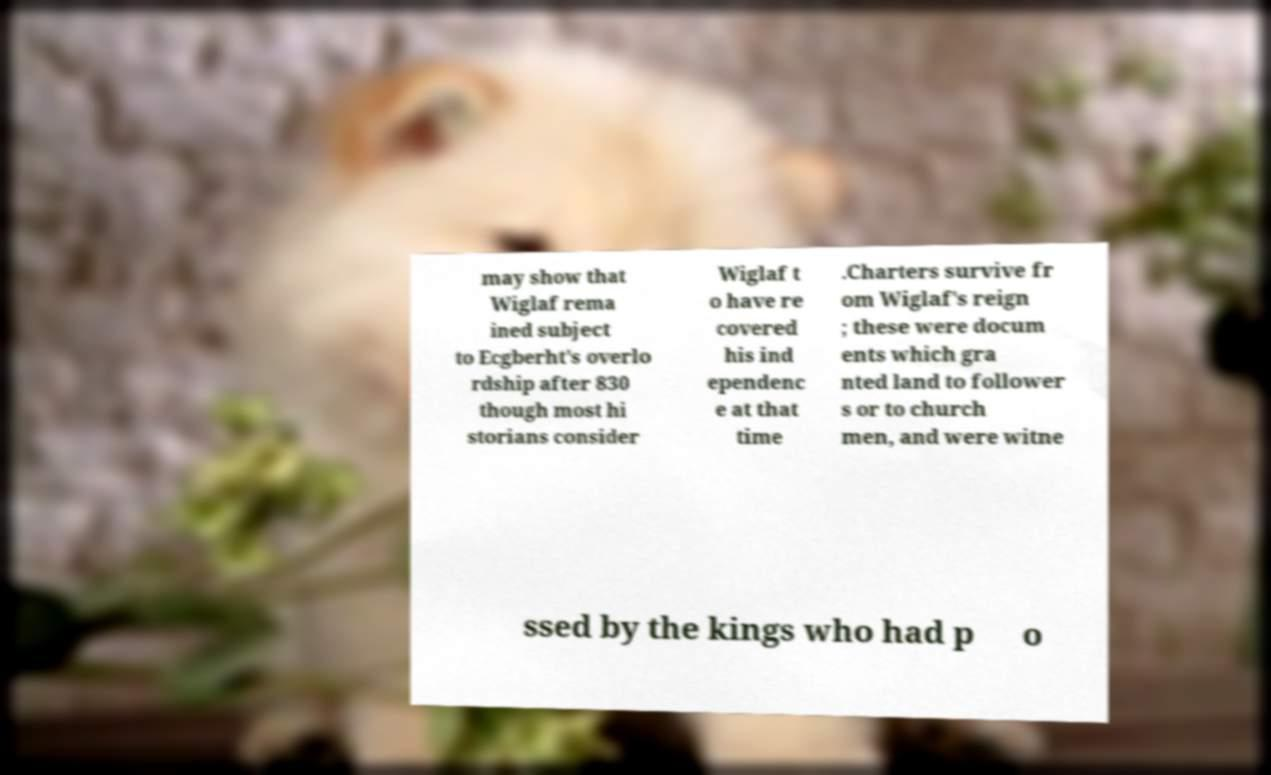Can you accurately transcribe the text from the provided image for me? may show that Wiglaf rema ined subject to Ecgberht's overlo rdship after 830 though most hi storians consider Wiglaf t o have re covered his ind ependenc e at that time .Charters survive fr om Wiglaf's reign ; these were docum ents which gra nted land to follower s or to church men, and were witne ssed by the kings who had p o 